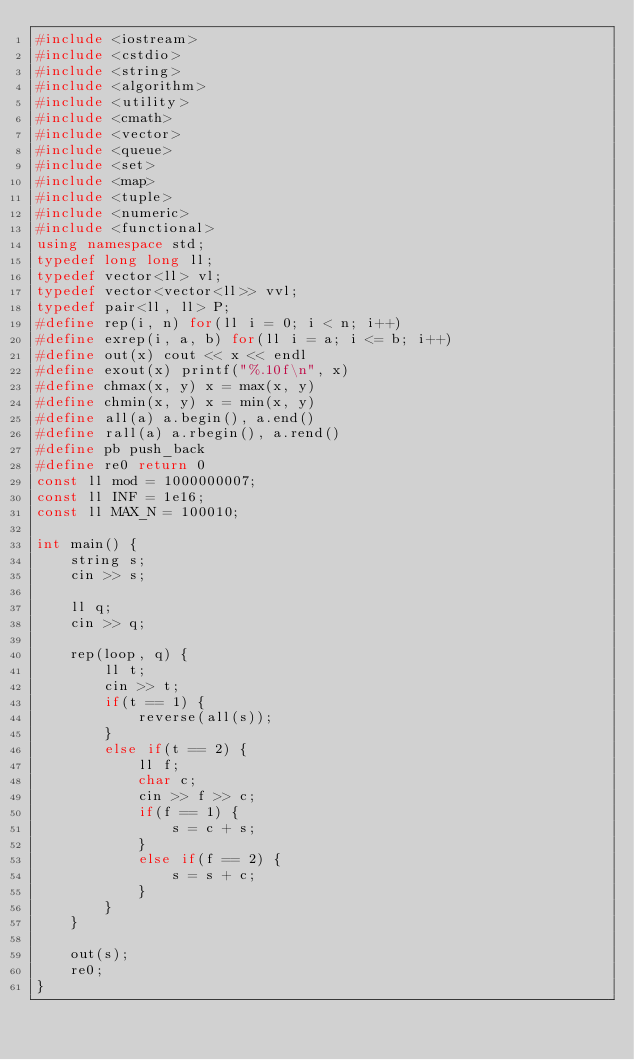<code> <loc_0><loc_0><loc_500><loc_500><_C++_>#include <iostream>
#include <cstdio>
#include <string>
#include <algorithm>
#include <utility>
#include <cmath>
#include <vector>
#include <queue>
#include <set>
#include <map>
#include <tuple>
#include <numeric>
#include <functional>
using namespace std;
typedef long long ll;
typedef vector<ll> vl;
typedef vector<vector<ll>> vvl;
typedef pair<ll, ll> P;
#define rep(i, n) for(ll i = 0; i < n; i++)
#define exrep(i, a, b) for(ll i = a; i <= b; i++)
#define out(x) cout << x << endl
#define exout(x) printf("%.10f\n", x)
#define chmax(x, y) x = max(x, y)
#define chmin(x, y) x = min(x, y)
#define all(a) a.begin(), a.end()
#define rall(a) a.rbegin(), a.rend()
#define pb push_back
#define re0 return 0
const ll mod = 1000000007;
const ll INF = 1e16;
const ll MAX_N = 100010;

int main() {
    string s;
    cin >> s;

    ll q;
    cin >> q;

    rep(loop, q) {
        ll t;
        cin >> t;
        if(t == 1) {
            reverse(all(s));
        }
        else if(t == 2) {
            ll f;
            char c;
            cin >> f >> c;
            if(f == 1) {
                s = c + s;
            }
            else if(f == 2) {
                s = s + c;
            }
        }
    }
    
    out(s);
    re0;
}</code> 